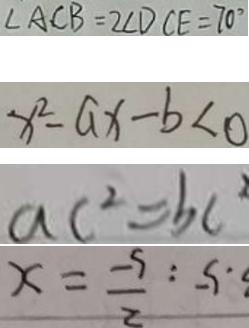<formula> <loc_0><loc_0><loc_500><loc_500>\angle A C B = 2 \angle D C E = 7 0 ^ { \circ } 
 x ^ { 2 } - a x - b < 0 
 a c ^ { 2 } = b c ^ { 2 } 
 . 5 : \frac { 2 } { 5 } = x</formula> 